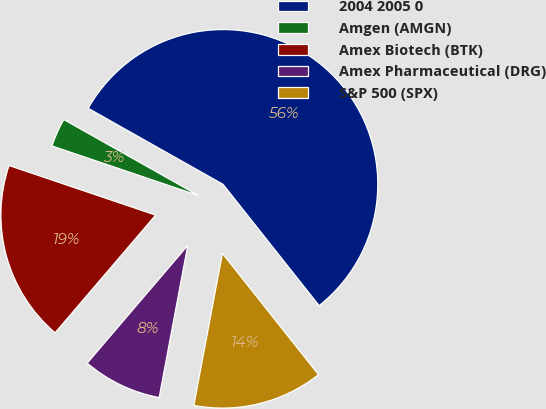<chart> <loc_0><loc_0><loc_500><loc_500><pie_chart><fcel>2004 2005 0<fcel>Amgen (AMGN)<fcel>Amex Biotech (BTK)<fcel>Amex Pharmaceutical (DRG)<fcel>S&P 500 (SPX)<nl><fcel>56.17%<fcel>2.98%<fcel>18.94%<fcel>8.3%<fcel>13.62%<nl></chart> 